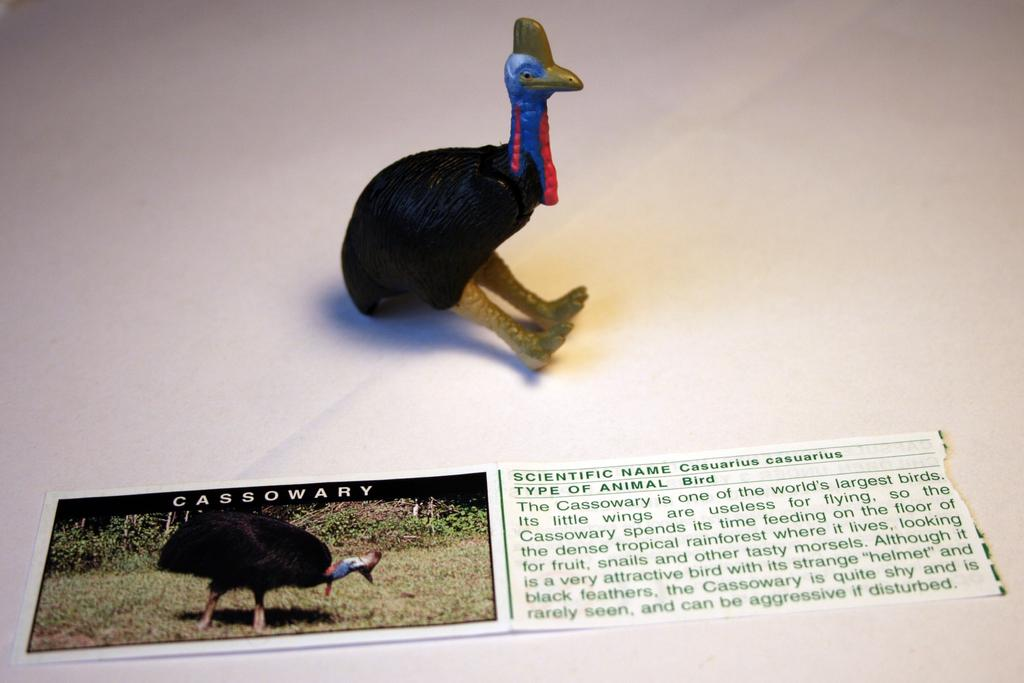What type of toy is present in the image? There is a toy of a bird in the image. What is depicted alongside the toy in the image? There is a picture of the bird in the image. What additional information is provided about the bird in the image? Some information is written beside the picture of the bird. What type of note is the bird playing in the image? There is no note or musical instrument present in the image; it only features a toy and a picture of a bird with accompanying information. 